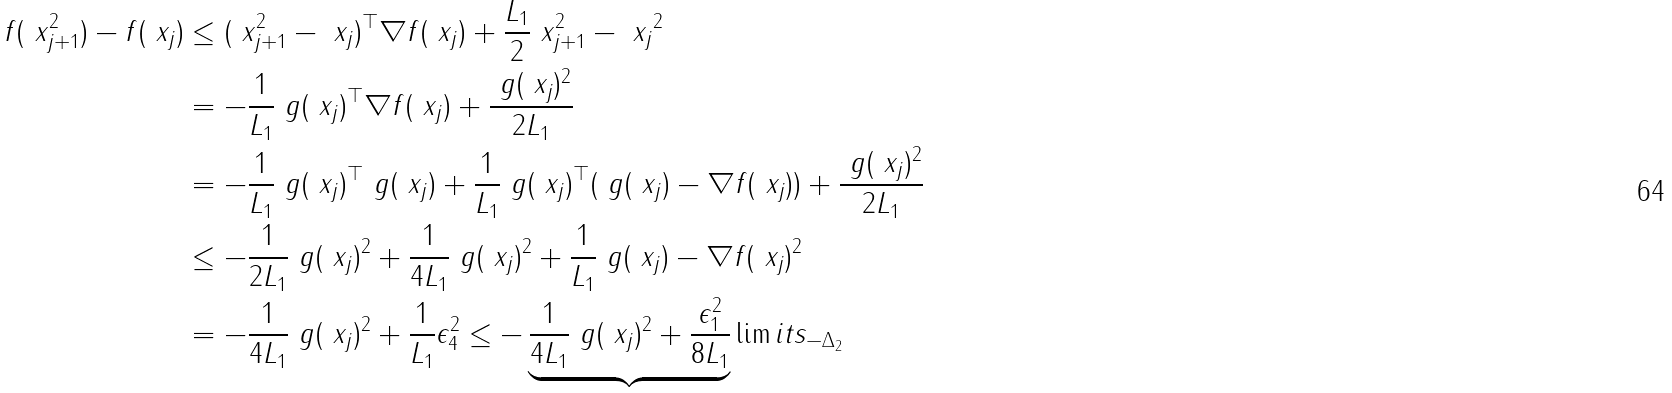<formula> <loc_0><loc_0><loc_500><loc_500>f ( \ x ^ { 2 } _ { j + 1 } ) - f ( \ x _ { j } ) & \leq ( \ x ^ { 2 } _ { j + 1 } - \ x _ { j } ) ^ { \top } \nabla f ( \ x _ { j } ) + \frac { L _ { 1 } } { 2 } \| \ x ^ { 2 } _ { j + 1 } - \ x _ { j } \| ^ { 2 } \\ & = - \frac { 1 } { L _ { 1 } } \ g ( \ x _ { j } ) ^ { \top } \nabla f ( \ x _ { j } ) + \frac { \| \ g ( \ x _ { j } ) \| ^ { 2 } } { 2 L _ { 1 } } \\ & = - \frac { 1 } { L _ { 1 } } \ g ( \ x _ { j } ) ^ { \top } \ g ( \ x _ { j } ) + \frac { 1 } { L _ { 1 } } \ g ( \ x _ { j } ) ^ { \top } ( \ g ( \ x _ { j } ) - \nabla f ( \ x _ { j } ) ) + \frac { \| \ g ( \ x _ { j } ) \| ^ { 2 } } { 2 L _ { 1 } } \\ & \leq - \frac { 1 } { 2 L _ { 1 } } \| \ g ( \ x _ { j } ) \| ^ { 2 } + \frac { 1 } { 4 L _ { 1 } } \| \ g ( \ x _ { j } ) \| ^ { 2 } + \frac { 1 } { L _ { 1 } } \| \ g ( \ x _ { j } ) - \nabla f ( \ x _ { j } ) \| ^ { 2 } \\ & = - \frac { 1 } { 4 L _ { 1 } } \| \ g ( \ x _ { j } ) \| ^ { 2 } + \frac { 1 } { L _ { 1 } } \epsilon _ { 4 } ^ { 2 } \leq - \underbrace { \frac { 1 } { 4 L _ { 1 } } \| \ g ( \ x _ { j } ) \| ^ { 2 } + \frac { \epsilon _ { 1 } ^ { 2 } } { 8 L _ { 1 } } } \lim i t s _ { - \Delta _ { 2 } } \\</formula> 